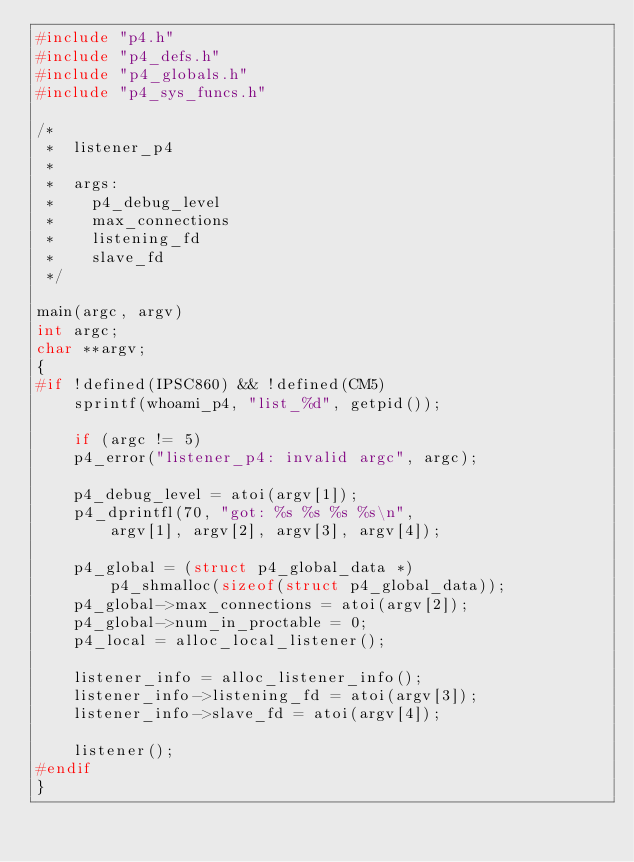Convert code to text. <code><loc_0><loc_0><loc_500><loc_500><_C_>#include "p4.h"
#include "p4_defs.h"
#include "p4_globals.h"
#include "p4_sys_funcs.h"

/*
 *  listener_p4
 *
 *  args:
 *    p4_debug_level
 *    max_connections
 *    listening_fd
 *    slave_fd
 */

main(argc, argv)
int argc;
char **argv;
{
#if !defined(IPSC860) && !defined(CM5)
    sprintf(whoami_p4, "list_%d", getpid());

    if (argc != 5)
	p4_error("listener_p4: invalid argc", argc);

    p4_debug_level = atoi(argv[1]);
    p4_dprintfl(70, "got: %s %s %s %s\n",
		argv[1], argv[2], argv[3], argv[4]);

    p4_global = (struct p4_global_data *)
		p4_shmalloc(sizeof(struct p4_global_data));
    p4_global->max_connections = atoi(argv[2]);
    p4_global->num_in_proctable = 0;
    p4_local = alloc_local_listener();

    listener_info = alloc_listener_info();
    listener_info->listening_fd = atoi(argv[3]);
    listener_info->slave_fd = atoi(argv[4]);

    listener();
#endif
}
</code> 